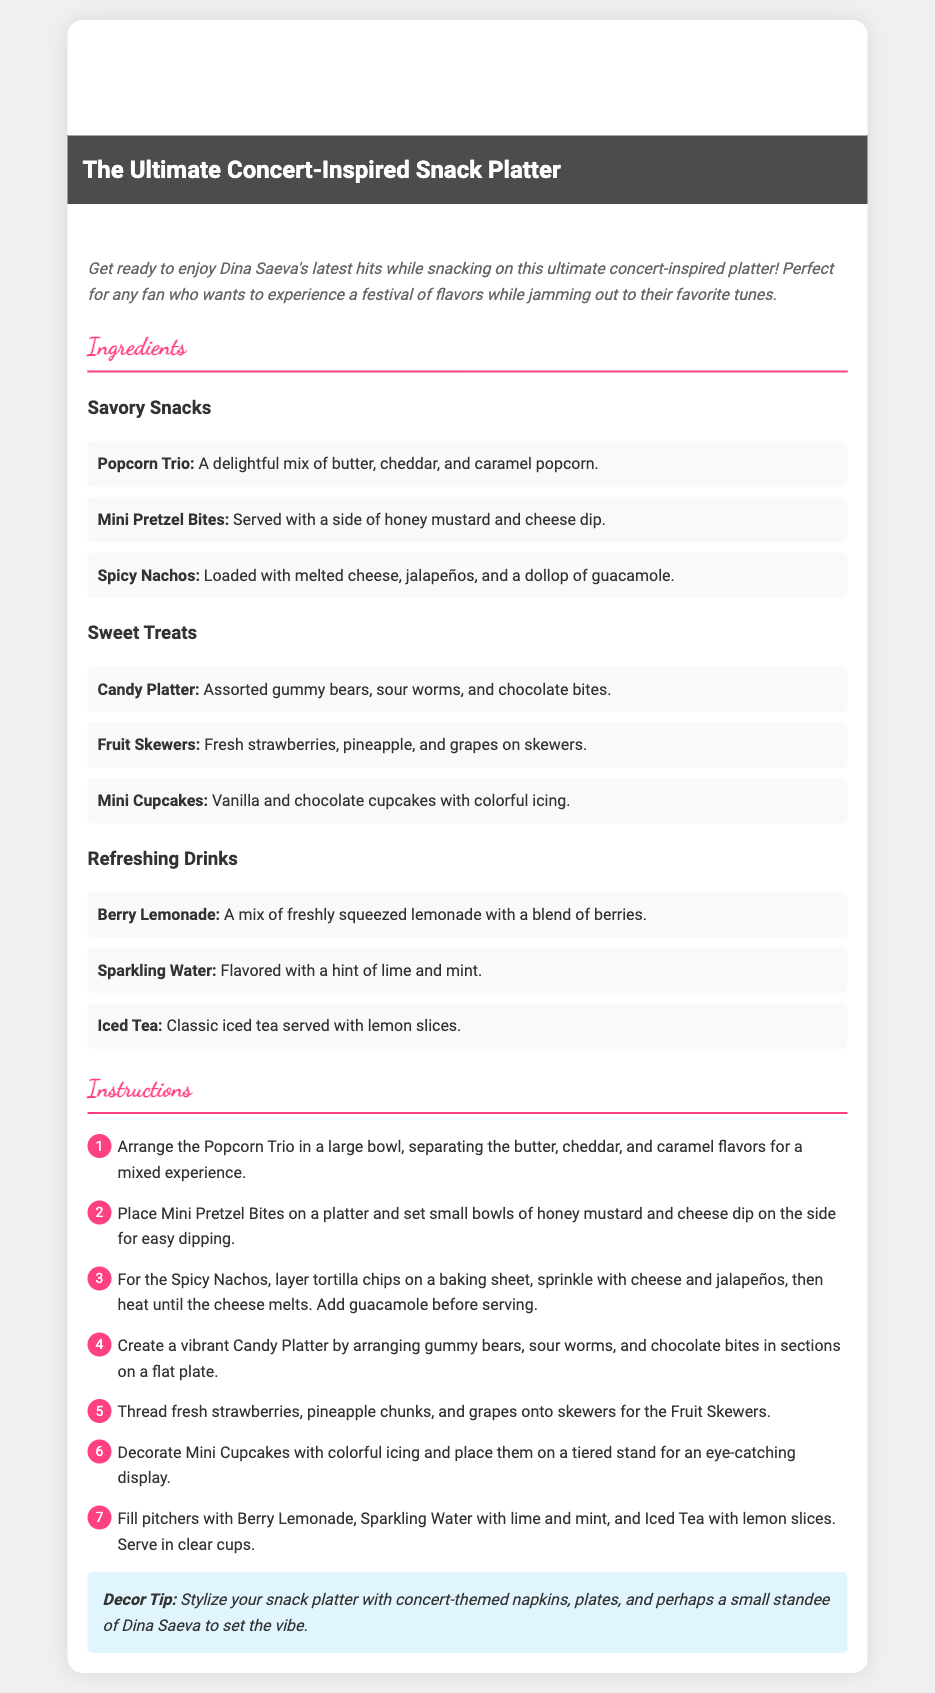What is the title of the recipe? The title is prominently displayed at the top of the document, indicating the focus of the recipe.
Answer: The Ultimate Concert-Inspired Snack Platter Who is the recipe card intended for? The introduction mentions that the recipe is perfect for fans enjoying Dina Saeva's music.
Answer: Fans of Dina Saeva How many ingredients are listed in the Savory Snacks section? There are three different snacks mentioned under Savory Snacks.
Answer: Three What are the ingredients for the Sweet Treats section? The listed ingredients for Sweet Treats include candy, fruit, and cupcakes, highlighting a variety of sweet options.
Answer: Candy Platter, Fruit Skewers, Mini Cupcakes Which drink includes a mix of lemonade and berries? The document specifies that Berry Lemonade is made with freshly squeezed lemonade and berries.
Answer: Berry Lemonade What is the first step in the instructions? The first instruction outlines how to arrange the Popcorn Trio in a bowl, emphasizing the snack preparation.
Answer: Arrange the Popcorn Trio in a large bowl What is suggested for decorating the platter? A decor tip in the document recommends using concert-themed items to enhance the platter's presentation.
Answer: Concert-themed napkins and plates Which ingredient is used for dipping with Mini Pretzel Bites? The instructions state that Mini Pretzel Bites are served with honey mustard and cheese dip for dipping.
Answer: Honey mustard and cheese dip How many steps are there in the instructions? The instructions list a total of seven steps to follow, indicating a well-structured preparation process.
Answer: Seven 